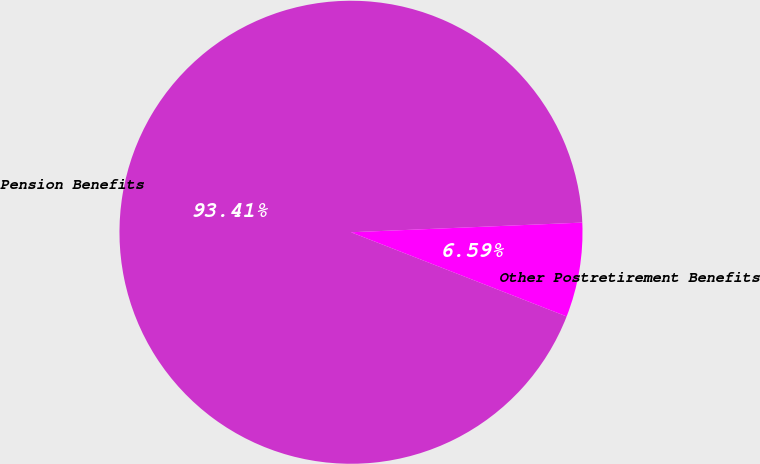Convert chart to OTSL. <chart><loc_0><loc_0><loc_500><loc_500><pie_chart><fcel>Pension Benefits<fcel>Other Postretirement Benefits<nl><fcel>93.41%<fcel>6.59%<nl></chart> 